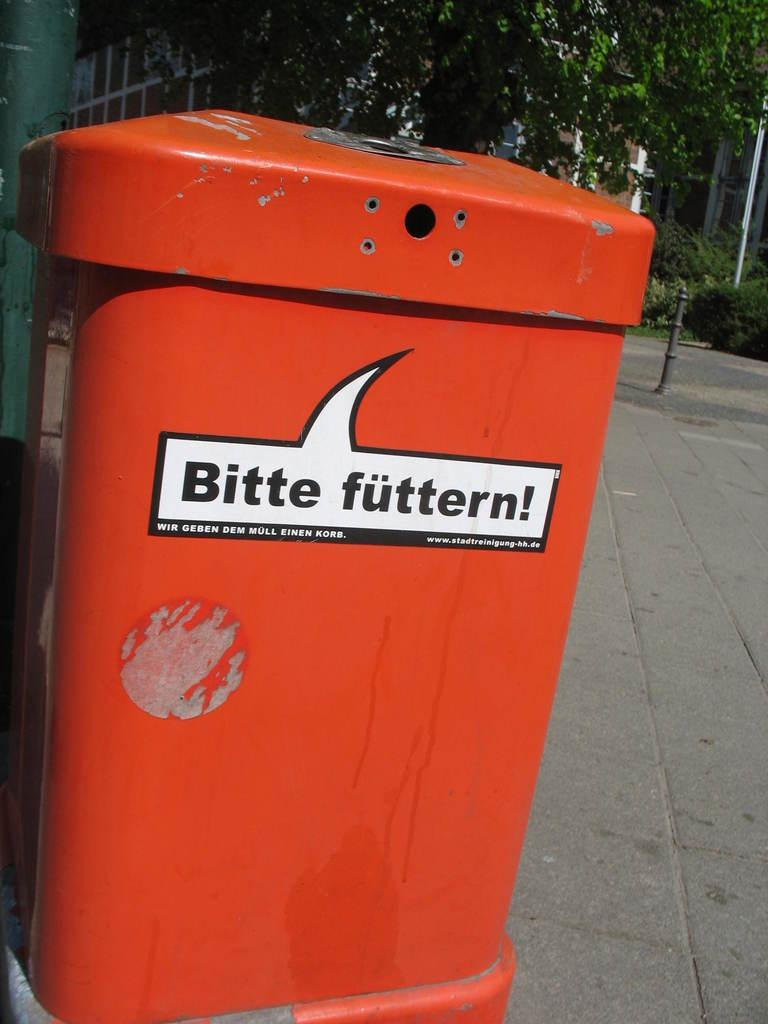<image>
Present a compact description of the photo's key features. The orange garbage can has a sticker that says, 'Bitte futtern!'. 